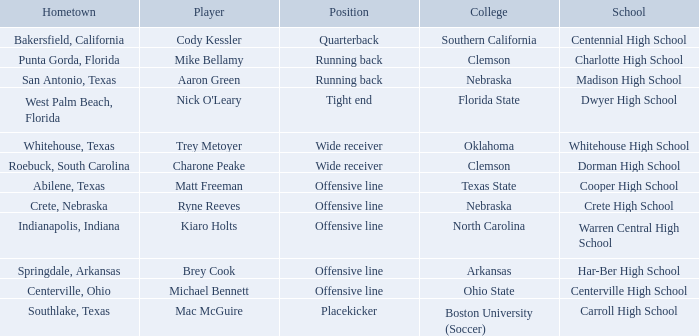What college did Matt Freeman go to? Texas State. 